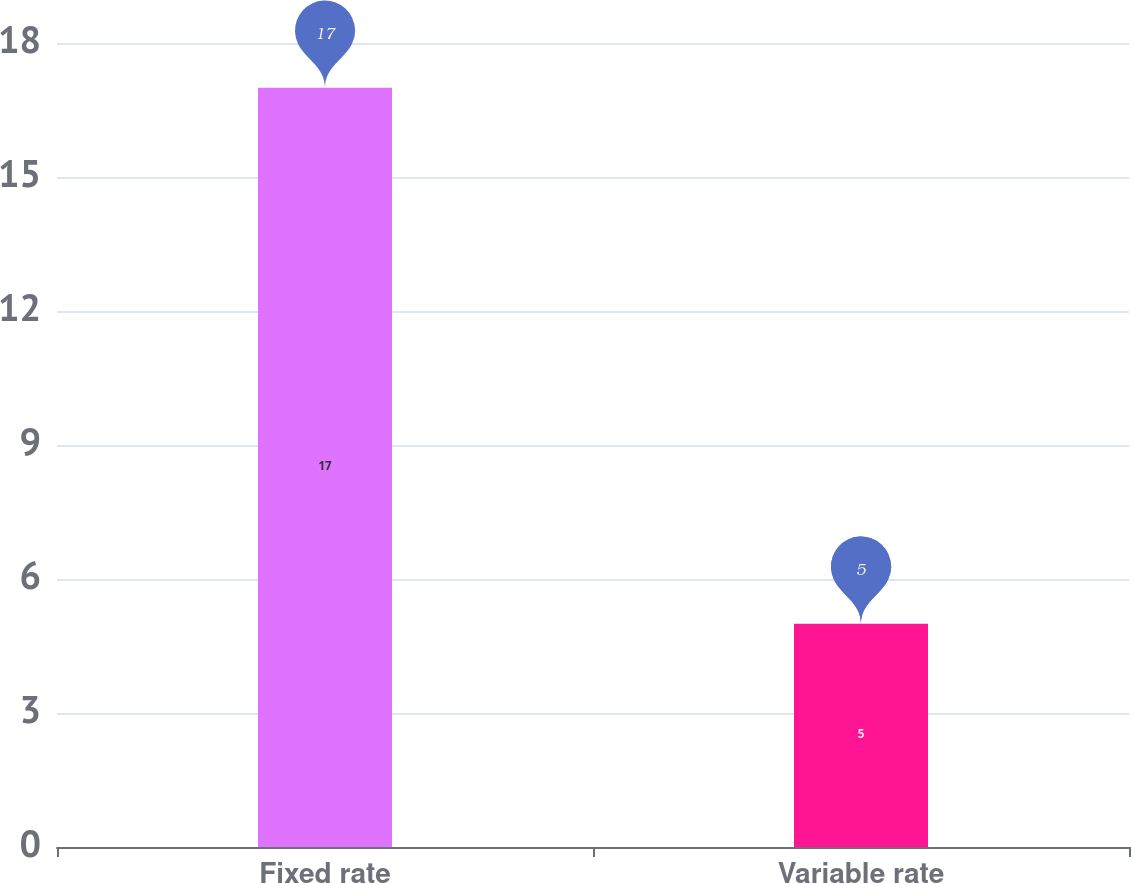Convert chart. <chart><loc_0><loc_0><loc_500><loc_500><bar_chart><fcel>Fixed rate<fcel>Variable rate<nl><fcel>17<fcel>5<nl></chart> 